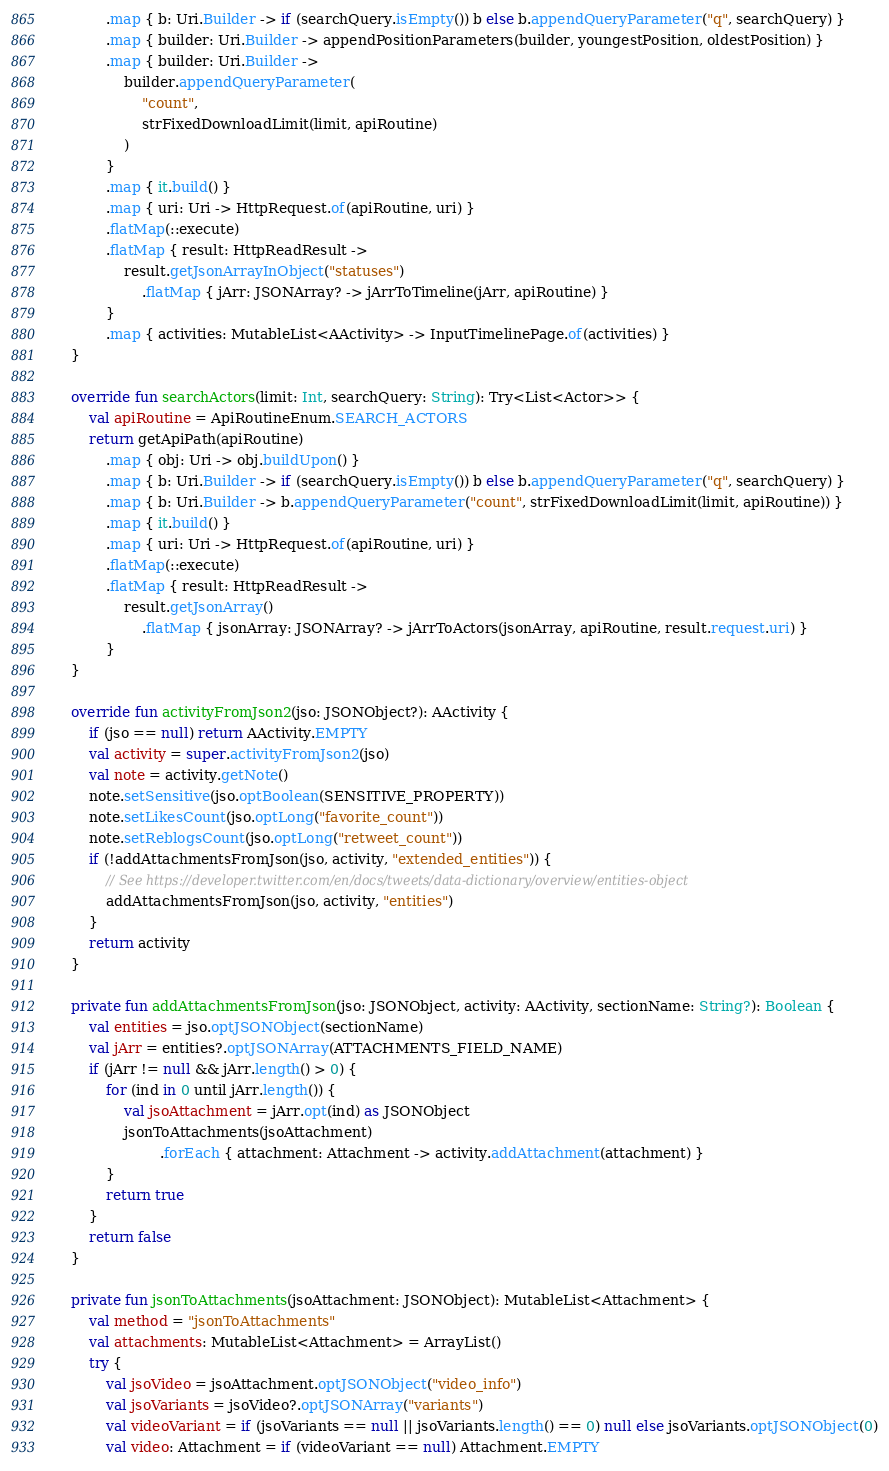<code> <loc_0><loc_0><loc_500><loc_500><_Kotlin_>            .map { b: Uri.Builder -> if (searchQuery.isEmpty()) b else b.appendQueryParameter("q", searchQuery) }
            .map { builder: Uri.Builder -> appendPositionParameters(builder, youngestPosition, oldestPosition) }
            .map { builder: Uri.Builder ->
                builder.appendQueryParameter(
                    "count",
                    strFixedDownloadLimit(limit, apiRoutine)
                )
            }
            .map { it.build() }
            .map { uri: Uri -> HttpRequest.of(apiRoutine, uri) }
            .flatMap(::execute)
            .flatMap { result: HttpReadResult ->
                result.getJsonArrayInObject("statuses")
                    .flatMap { jArr: JSONArray? -> jArrToTimeline(jArr, apiRoutine) }
            }
            .map { activities: MutableList<AActivity> -> InputTimelinePage.of(activities) }
    }

    override fun searchActors(limit: Int, searchQuery: String): Try<List<Actor>> {
        val apiRoutine = ApiRoutineEnum.SEARCH_ACTORS
        return getApiPath(apiRoutine)
            .map { obj: Uri -> obj.buildUpon() }
            .map { b: Uri.Builder -> if (searchQuery.isEmpty()) b else b.appendQueryParameter("q", searchQuery) }
            .map { b: Uri.Builder -> b.appendQueryParameter("count", strFixedDownloadLimit(limit, apiRoutine)) }
            .map { it.build() }
            .map { uri: Uri -> HttpRequest.of(apiRoutine, uri) }
            .flatMap(::execute)
            .flatMap { result: HttpReadResult ->
                result.getJsonArray()
                    .flatMap { jsonArray: JSONArray? -> jArrToActors(jsonArray, apiRoutine, result.request.uri) }
            }
    }

    override fun activityFromJson2(jso: JSONObject?): AActivity {
        if (jso == null) return AActivity.EMPTY
        val activity = super.activityFromJson2(jso)
        val note = activity.getNote()
        note.setSensitive(jso.optBoolean(SENSITIVE_PROPERTY))
        note.setLikesCount(jso.optLong("favorite_count"))
        note.setReblogsCount(jso.optLong("retweet_count"))
        if (!addAttachmentsFromJson(jso, activity, "extended_entities")) {
            // See https://developer.twitter.com/en/docs/tweets/data-dictionary/overview/entities-object
            addAttachmentsFromJson(jso, activity, "entities")
        }
        return activity
    }

    private fun addAttachmentsFromJson(jso: JSONObject, activity: AActivity, sectionName: String?): Boolean {
        val entities = jso.optJSONObject(sectionName)
        val jArr = entities?.optJSONArray(ATTACHMENTS_FIELD_NAME)
        if (jArr != null && jArr.length() > 0) {
            for (ind in 0 until jArr.length()) {
                val jsoAttachment = jArr.opt(ind) as JSONObject
                jsonToAttachments(jsoAttachment)
                        .forEach { attachment: Attachment -> activity.addAttachment(attachment) }
            }
            return true
        }
        return false
    }

    private fun jsonToAttachments(jsoAttachment: JSONObject): MutableList<Attachment> {
        val method = "jsonToAttachments"
        val attachments: MutableList<Attachment> = ArrayList()
        try {
            val jsoVideo = jsoAttachment.optJSONObject("video_info")
            val jsoVariants = jsoVideo?.optJSONArray("variants")
            val videoVariant = if (jsoVariants == null || jsoVariants.length() == 0) null else jsoVariants.optJSONObject(0)
            val video: Attachment = if (videoVariant == null) Attachment.EMPTY</code> 